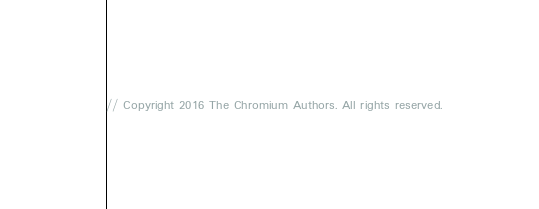Convert code to text. <code><loc_0><loc_0><loc_500><loc_500><_ObjectiveC_>// Copyright 2016 The Chromium Authors. All rights reserved.</code> 